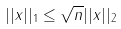<formula> <loc_0><loc_0><loc_500><loc_500>| | x | | _ { 1 } \leq \sqrt { n } | | x | | _ { 2 }</formula> 